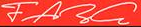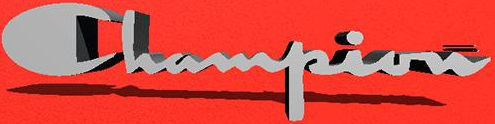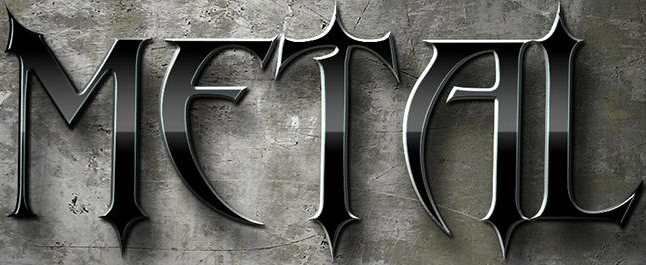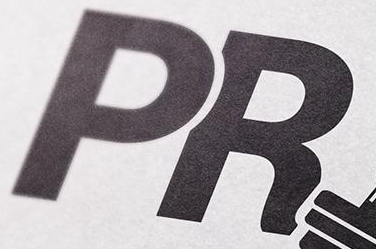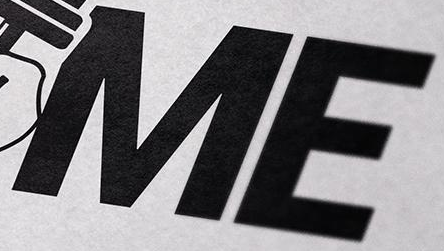Read the text content from these images in order, separated by a semicolon. FARG; Champion; METAL; PR; ME 